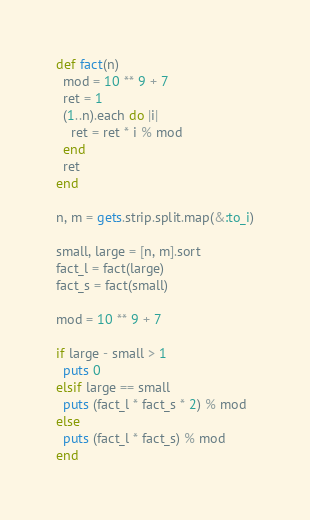Convert code to text. <code><loc_0><loc_0><loc_500><loc_500><_Ruby_>def fact(n)
  mod = 10 ** 9 + 7
  ret = 1
  (1..n).each do |i|
    ret = ret * i % mod
  end
  ret
end

n, m = gets.strip.split.map(&:to_i)

small, large = [n, m].sort
fact_l = fact(large)
fact_s = fact(small)

mod = 10 ** 9 + 7

if large - small > 1
  puts 0
elsif large == small
  puts (fact_l * fact_s * 2) % mod
else
  puts (fact_l * fact_s) % mod
end
</code> 